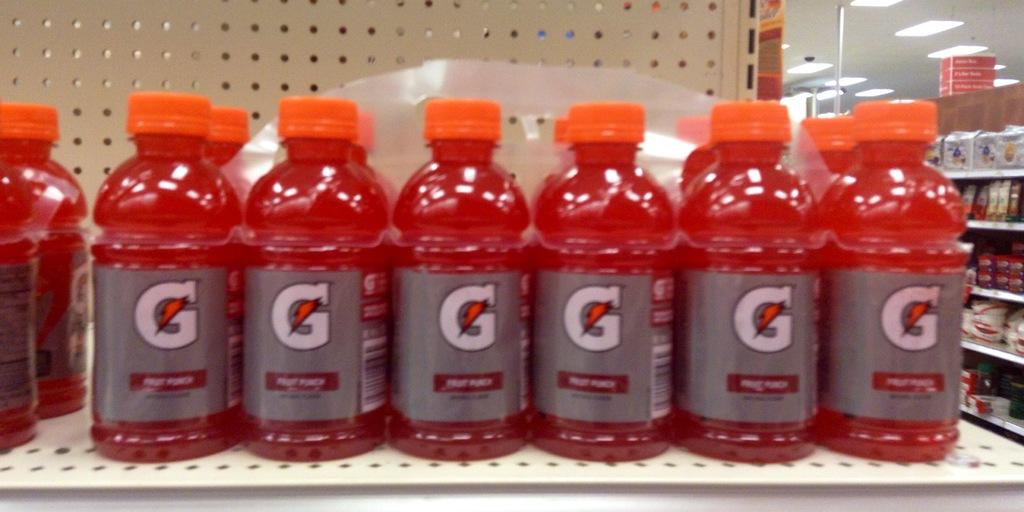Provide a one-sentence caption for the provided image. store shelf containing fruit punch flavored gatoraid that have silver labels and orange caps. 